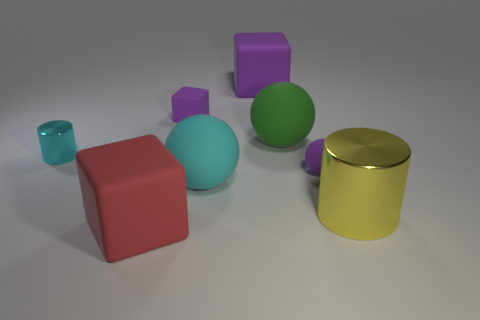Add 2 matte balls. How many objects exist? 10 Subtract all spheres. How many objects are left? 5 Subtract all tiny purple cubes. Subtract all green spheres. How many objects are left? 6 Add 5 large yellow shiny cylinders. How many large yellow shiny cylinders are left? 6 Add 7 purple rubber spheres. How many purple rubber spheres exist? 8 Subtract 0 red cylinders. How many objects are left? 8 